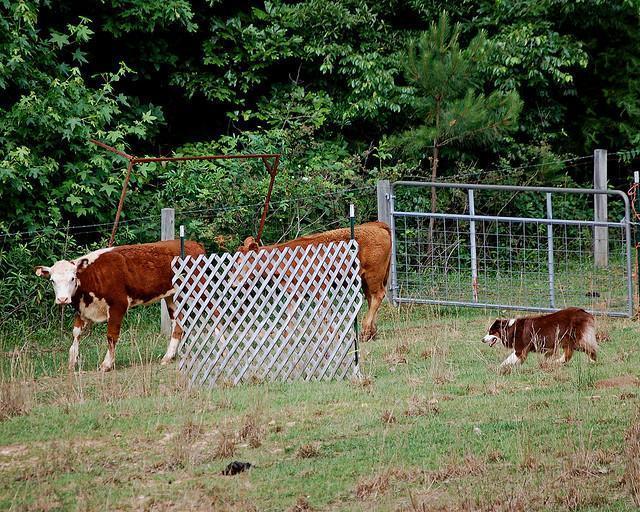How many cows are in the picture?
Give a very brief answer. 2. How many horns does the animal on the left have?
Give a very brief answer. 0. How many cows are there?
Give a very brief answer. 2. How many people are wearing a white shirt?
Give a very brief answer. 0. 